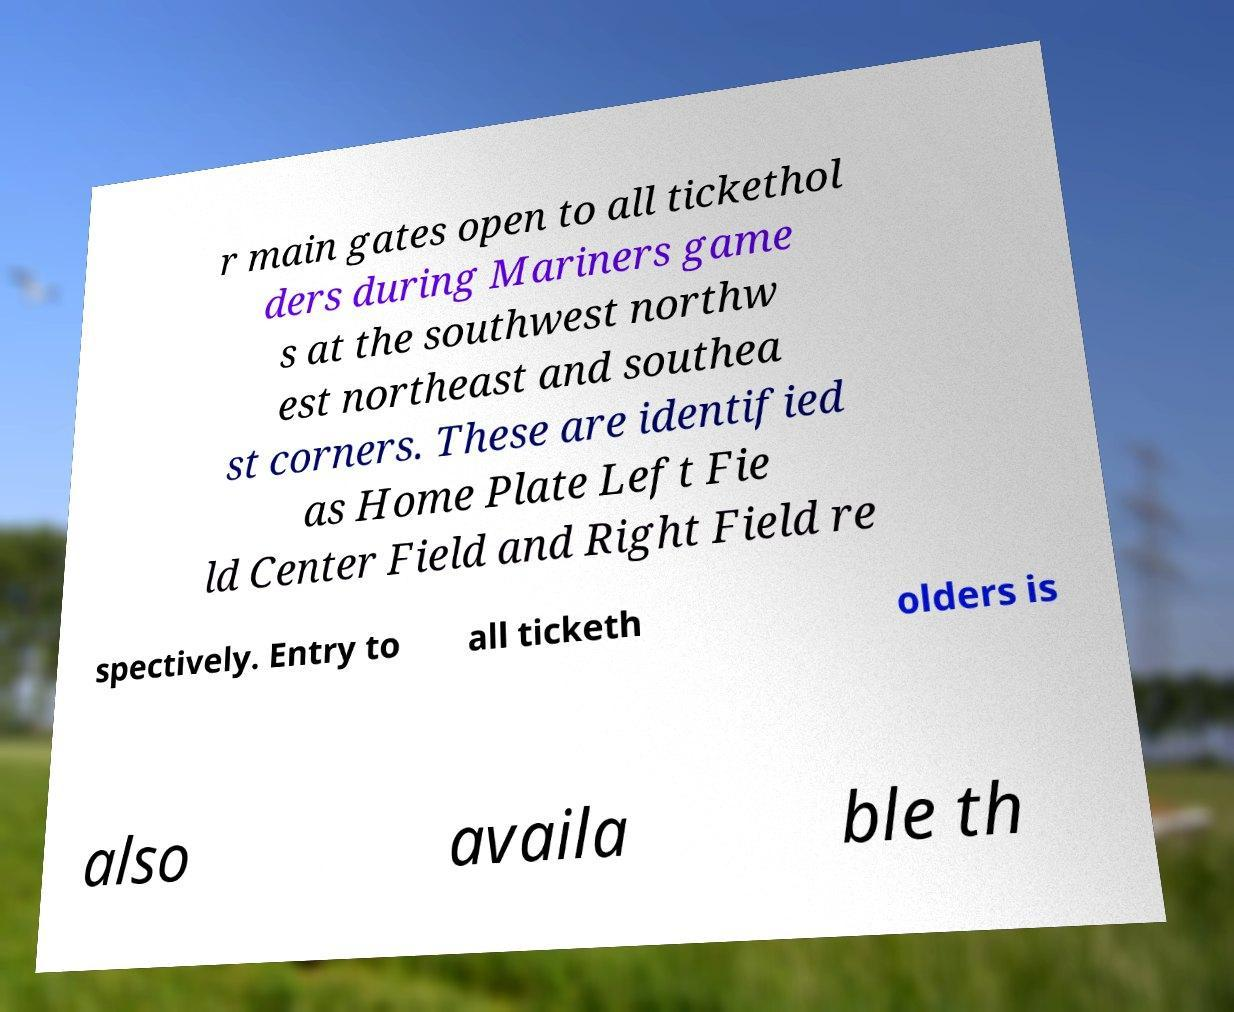What messages or text are displayed in this image? I need them in a readable, typed format. r main gates open to all tickethol ders during Mariners game s at the southwest northw est northeast and southea st corners. These are identified as Home Plate Left Fie ld Center Field and Right Field re spectively. Entry to all ticketh olders is also availa ble th 